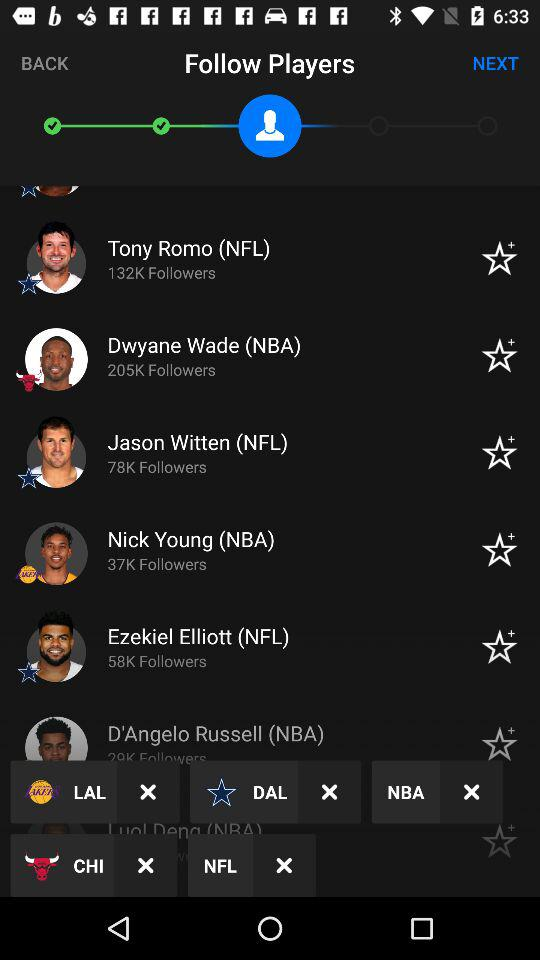How many followers does Ezekiel Elliott have? Ezekiel Elliott has 58K followers. 